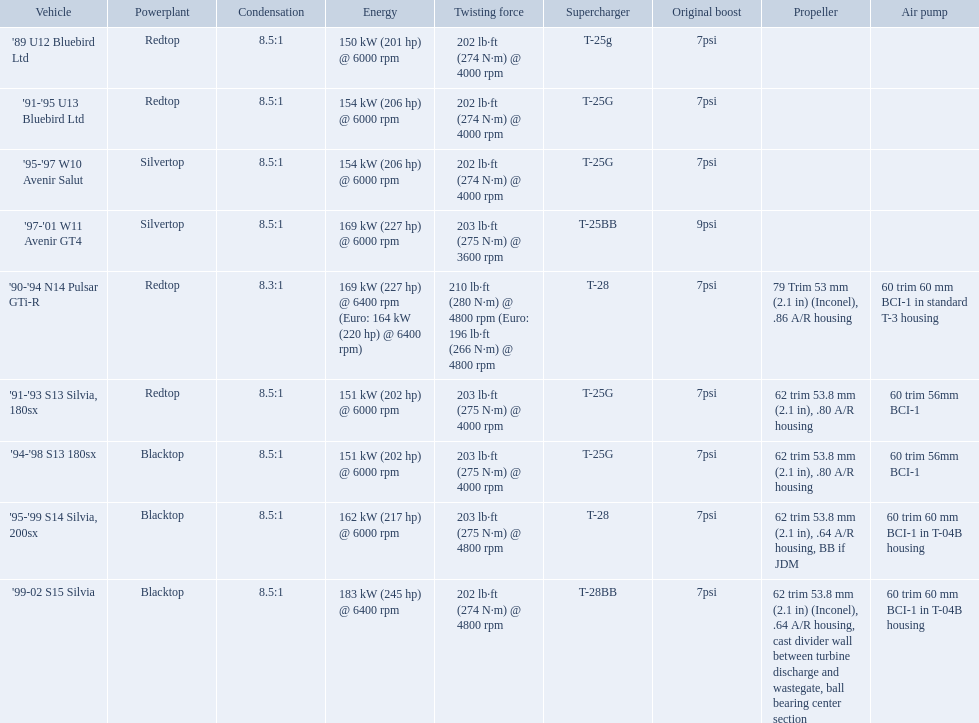Which cars featured blacktop engines? '94-'98 S13 180sx, '95-'99 S14 Silvia, 200sx, '99-02 S15 Silvia. Which of these had t-04b compressor housings? '95-'99 S14 Silvia, 200sx, '99-02 S15 Silvia. Which one of these has the highest horsepower? '99-02 S15 Silvia. What are all of the cars? '89 U12 Bluebird Ltd, '91-'95 U13 Bluebird Ltd, '95-'97 W10 Avenir Salut, '97-'01 W11 Avenir GT4, '90-'94 N14 Pulsar GTi-R, '91-'93 S13 Silvia, 180sx, '94-'98 S13 180sx, '95-'99 S14 Silvia, 200sx, '99-02 S15 Silvia. What is their rated power? 150 kW (201 hp) @ 6000 rpm, 154 kW (206 hp) @ 6000 rpm, 154 kW (206 hp) @ 6000 rpm, 169 kW (227 hp) @ 6000 rpm, 169 kW (227 hp) @ 6400 rpm (Euro: 164 kW (220 hp) @ 6400 rpm), 151 kW (202 hp) @ 6000 rpm, 151 kW (202 hp) @ 6000 rpm, 162 kW (217 hp) @ 6000 rpm, 183 kW (245 hp) @ 6400 rpm. Which car has the most power? '99-02 S15 Silvia. What cars are there? '89 U12 Bluebird Ltd, 7psi, '91-'95 U13 Bluebird Ltd, 7psi, '95-'97 W10 Avenir Salut, 7psi, '97-'01 W11 Avenir GT4, 9psi, '90-'94 N14 Pulsar GTi-R, 7psi, '91-'93 S13 Silvia, 180sx, 7psi, '94-'98 S13 180sx, 7psi, '95-'99 S14 Silvia, 200sx, 7psi, '99-02 S15 Silvia, 7psi. Which stock boost is over 7psi? '97-'01 W11 Avenir GT4, 9psi. What car is it? '97-'01 W11 Avenir GT4. Which cars list turbine details? '90-'94 N14 Pulsar GTi-R, '91-'93 S13 Silvia, 180sx, '94-'98 S13 180sx, '95-'99 S14 Silvia, 200sx, '99-02 S15 Silvia. Which of these hit their peak hp at the highest rpm? '90-'94 N14 Pulsar GTi-R, '99-02 S15 Silvia. Of those what is the compression of the only engine that isn't blacktop?? 8.3:1. 